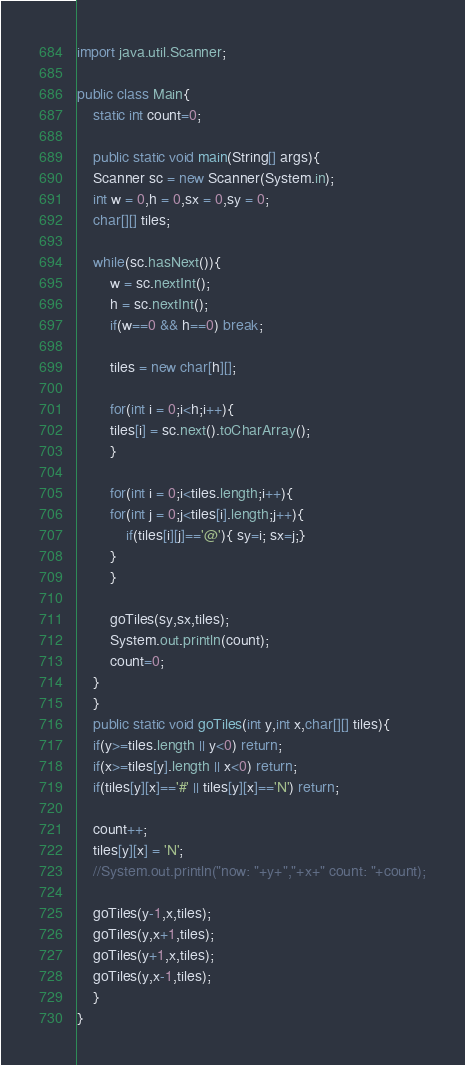Convert code to text. <code><loc_0><loc_0><loc_500><loc_500><_Java_>import java.util.Scanner;

public class Main{
    static int count=0;

    public static void main(String[] args){
	Scanner sc = new Scanner(System.in);
	int w = 0,h = 0,sx = 0,sy = 0;
	char[][] tiles;
	
	while(sc.hasNext()){
	    w = sc.nextInt();
	    h = sc.nextInt();
	    if(w==0 && h==0) break;

	    tiles = new char[h][];

	    for(int i = 0;i<h;i++){
		tiles[i] = sc.next().toCharArray();
	    }
	    
	    for(int i = 0;i<tiles.length;i++){
		for(int j = 0;j<tiles[i].length;j++){
		    if(tiles[i][j]=='@'){ sy=i; sx=j;}
		}
	    }
	    
	    goTiles(sy,sx,tiles);
	    System.out.println(count);
	    count=0;
	}
    }
    public static void goTiles(int y,int x,char[][] tiles){
	if(y>=tiles.length || y<0) return;
	if(x>=tiles[y].length || x<0) return;
	if(tiles[y][x]=='#' || tiles[y][x]=='N') return;
	
	count++;
	tiles[y][x] = 'N';
	//System.out.println("now: "+y+","+x+" count: "+count);
	
	goTiles(y-1,x,tiles);
	goTiles(y,x+1,tiles);
	goTiles(y+1,x,tiles);
	goTiles(y,x-1,tiles);
    }
}</code> 